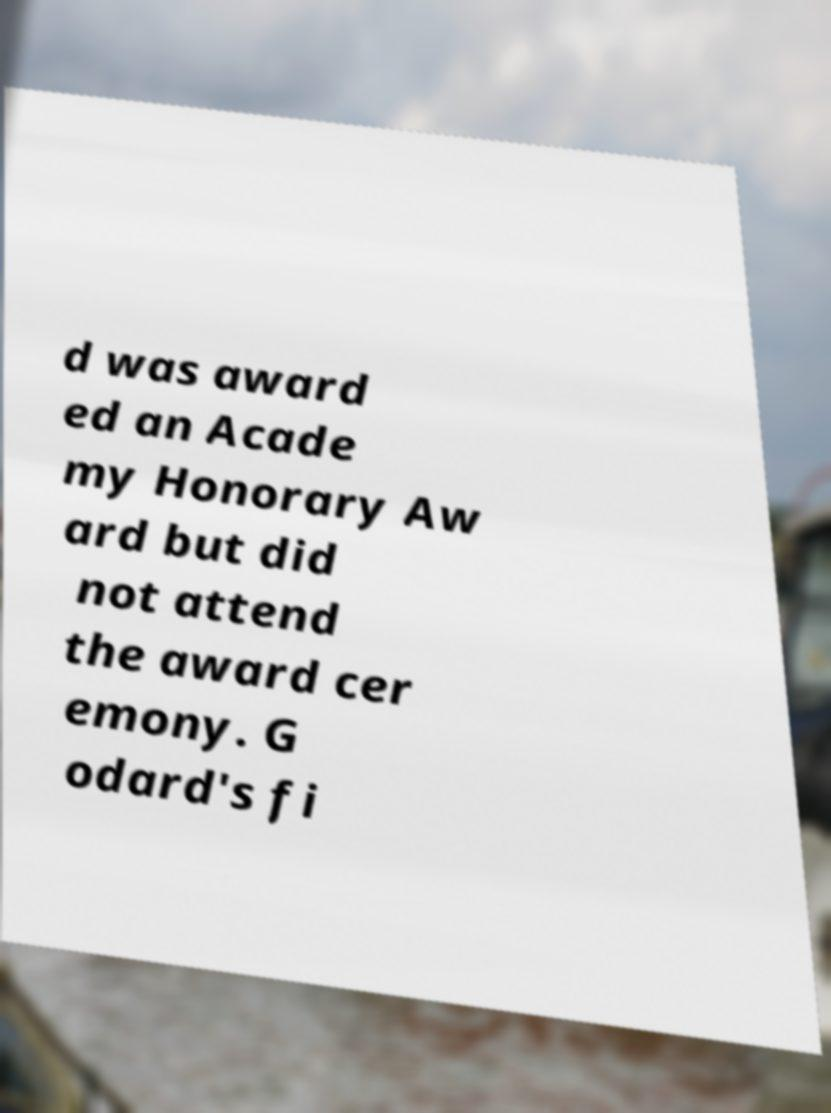Could you assist in decoding the text presented in this image and type it out clearly? d was award ed an Acade my Honorary Aw ard but did not attend the award cer emony. G odard's fi 